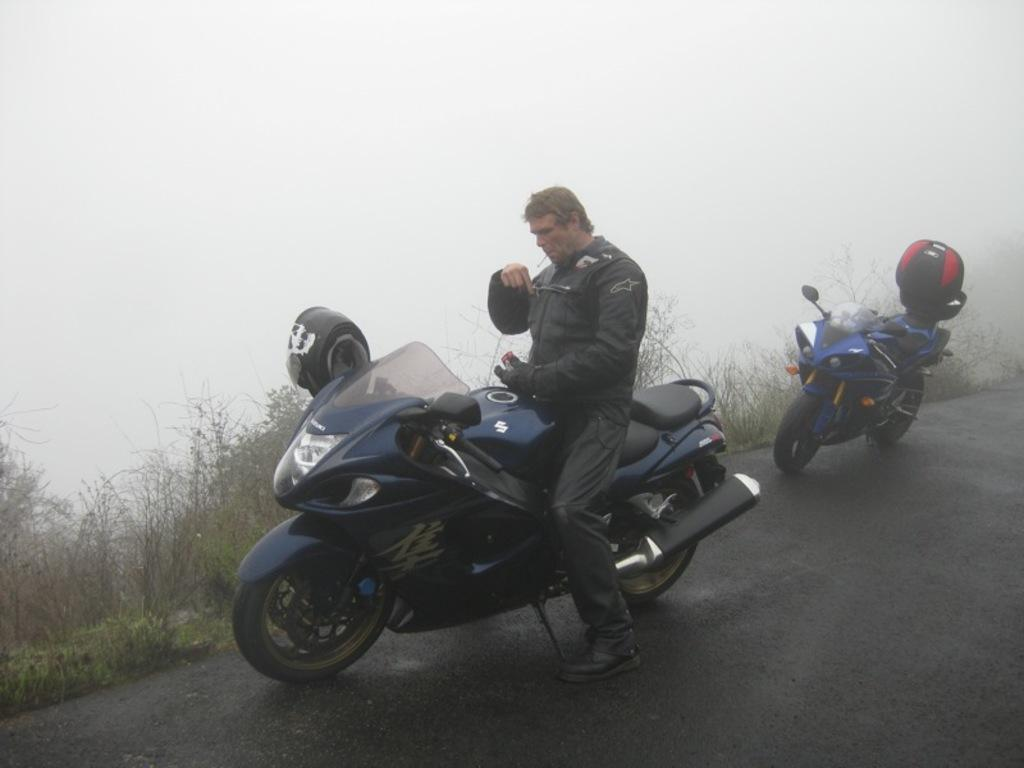What is the person in the image doing? The person is standing on a motorcycle. Can you describe the motorcycle behind the person? There is another blue motorcycle behind the person. What safety gear is present near the blue motorcycle? A helmet is present at the back of the blue motorcycle. What can be seen in the background of the image? There are plants and fog visible in the background. How many horses are present in the image? There are no horses present in the image; it features motorcycles and a person. What type of button can be seen on the person's clothing in the image? There is no button visible on the person's clothing in the image. 